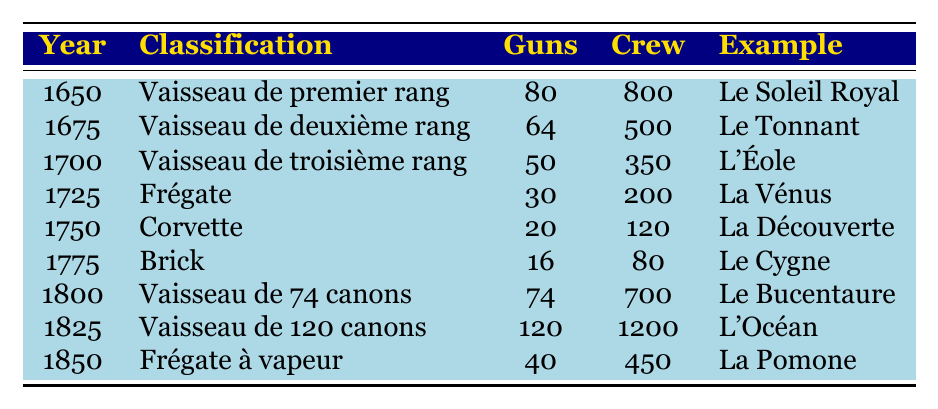What ship classification was used in 1800? The table indicates that in the year 1800, the classification was "Vaisseau de 74 canons."
Answer: Vaisseau de 74 canons How many guns did the ship "Le Tonnant" have? Referring to the table, "Le Tonnant" is categorized under "Vaisseau de deuxième rang," which had 64 guns.
Answer: 64 Which ship had the largest crew in the table? By examining the crew numbers in the table, "L'Océan," categorized as "Vaisseau de 120 canons," had a crew of 1200, which is the highest.
Answer: L'Océan Is "La Pomone" a type of frigate? The table lists "La Pomone" under the classification "Frégate à vapeur," confirming that it is indeed a type of frigate.
Answer: Yes What is the difference in crew size between the "Vaisseau de premier rang" and the "Corvette"? From the table, "Vaisseau de premier rang" had a crew of 800 and "Corvette" had a crew of 120. Therefore, the difference is 800 - 120 = 680.
Answer: 680 Calculate the average number of guns across all classified ships in the table. The guns for all ships are: 80, 64, 50, 30, 20, 16, 74, 120, 40. Summing them gives 80 + 64 + 50 + 30 + 20 + 16 + 74 + 120 + 40 = 474. There are 9 entries, so the average is 474 / 9 = 52.67.
Answer: 52.67 Which was the earliest ship to have less than 50 guns? Scanning the years from the table, the "Frégate" classification in 1725, which had 30 guns, was the earliest classification with less than 50 guns.
Answer: Frégate Is there a ship with the same number of guns as the "Brick"? The "Brick" has 16 guns. Looking through the table, there are no other classifications listed with 16 guns.
Answer: No What classification was introduced in 1725 and what was its crew size? According to the table, the classification introduced in 1725 is "Frégate," which had a crew size of 200.
Answer: Frégate, 200 Summarize the classifications present in the year 1750. The classification in 1750 is "Corvette," with 20 guns and a crew of 120. This is the only classification present for that year in the table.
Answer: Corvette, 20 guns, crew 120 